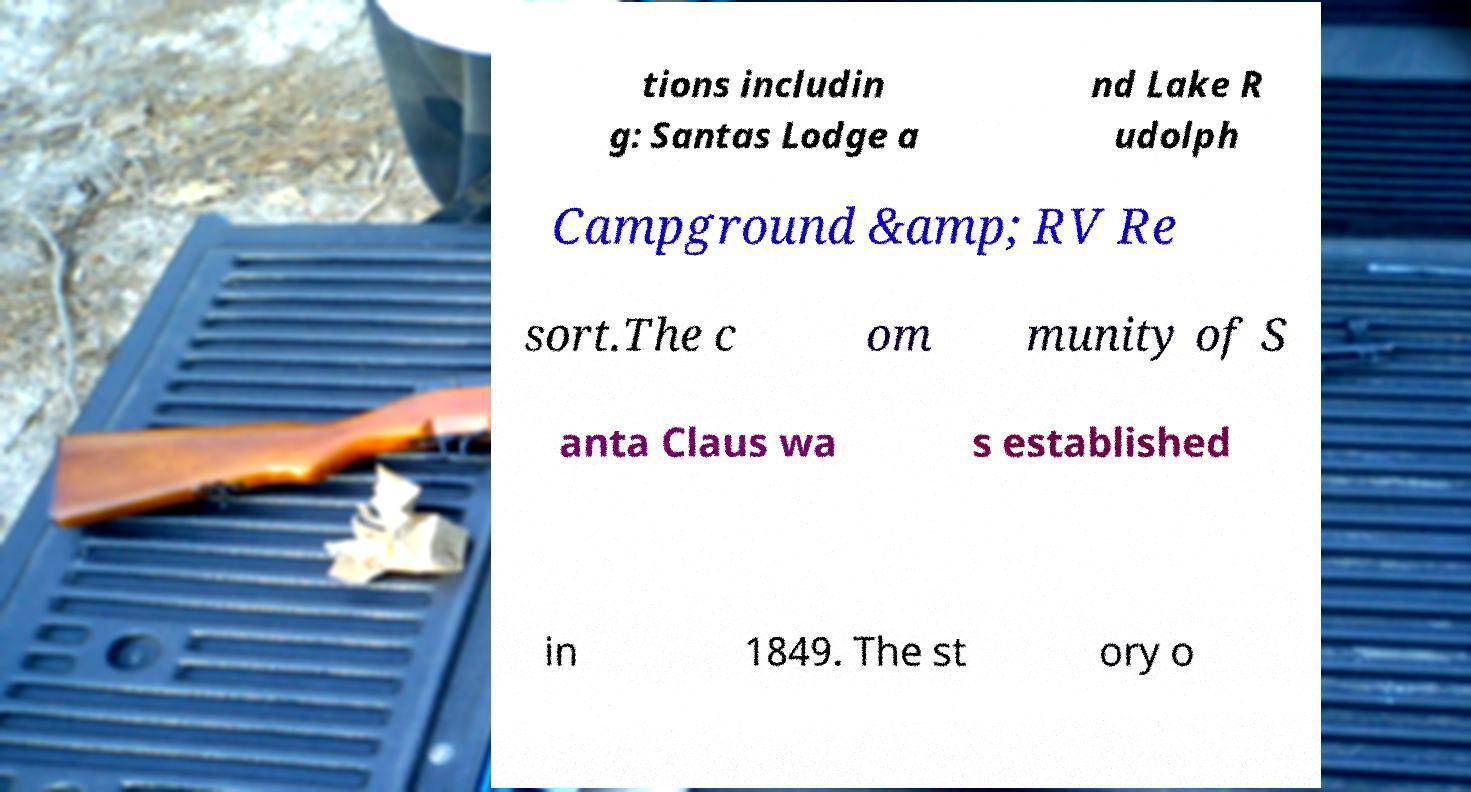Please identify and transcribe the text found in this image. tions includin g: Santas Lodge a nd Lake R udolph Campground &amp; RV Re sort.The c om munity of S anta Claus wa s established in 1849. The st ory o 